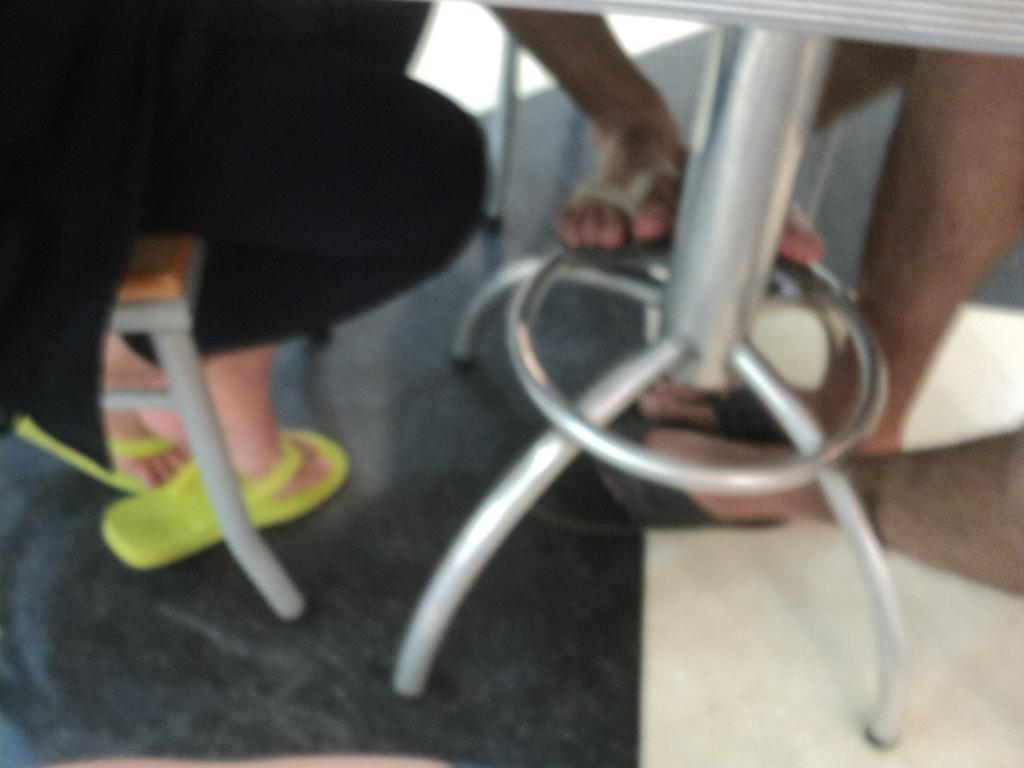How many people are in the image? There are persons in the image. What are the persons doing in the image? The persons are sitting on chairs. What is in front of the chairs? There is a table in front of the chairs. What type of plants can be seen growing in the jail in the image? There is no jail or plants present in the image; it features persons sitting on chairs with a table in front of them. 